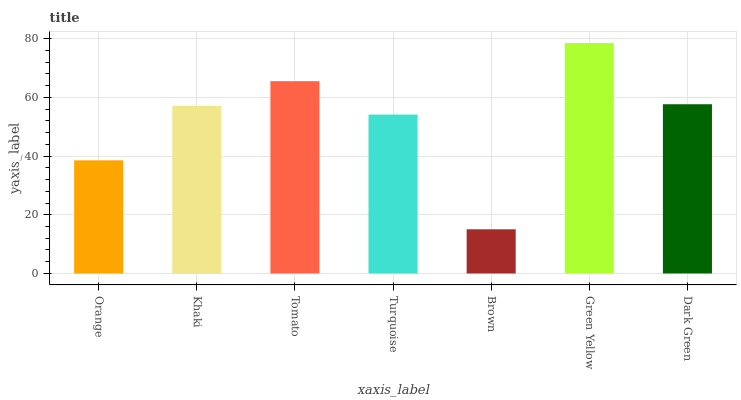Is Brown the minimum?
Answer yes or no. Yes. Is Green Yellow the maximum?
Answer yes or no. Yes. Is Khaki the minimum?
Answer yes or no. No. Is Khaki the maximum?
Answer yes or no. No. Is Khaki greater than Orange?
Answer yes or no. Yes. Is Orange less than Khaki?
Answer yes or no. Yes. Is Orange greater than Khaki?
Answer yes or no. No. Is Khaki less than Orange?
Answer yes or no. No. Is Khaki the high median?
Answer yes or no. Yes. Is Khaki the low median?
Answer yes or no. Yes. Is Tomato the high median?
Answer yes or no. No. Is Orange the low median?
Answer yes or no. No. 